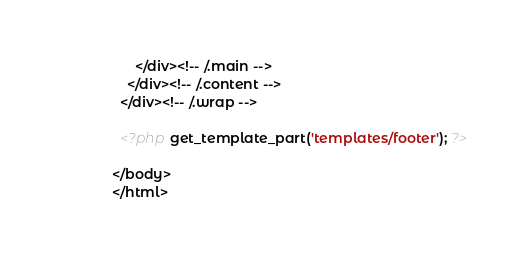Convert code to text. <code><loc_0><loc_0><loc_500><loc_500><_PHP_>      </div><!-- /.main -->
    </div><!-- /.content -->
  </div><!-- /.wrap -->

  <?php get_template_part('templates/footer'); ?>

</body>
</html>
</code> 